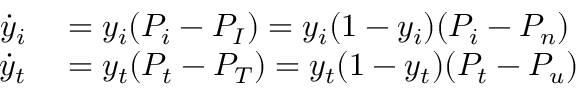Convert formula to latex. <formula><loc_0><loc_0><loc_500><loc_500>\begin{array} { r l } { \dot { y } _ { i } } & = y _ { i } ( P _ { i } - P _ { I } ) = y _ { i } ( 1 - y _ { i } ) ( P _ { i } - P _ { n } ) } \\ { \dot { y } _ { t } } & = y _ { t } ( P _ { t } - P _ { T } ) = y _ { t } ( 1 - y _ { t } ) ( P _ { t } - P _ { u } ) } \end{array}</formula> 